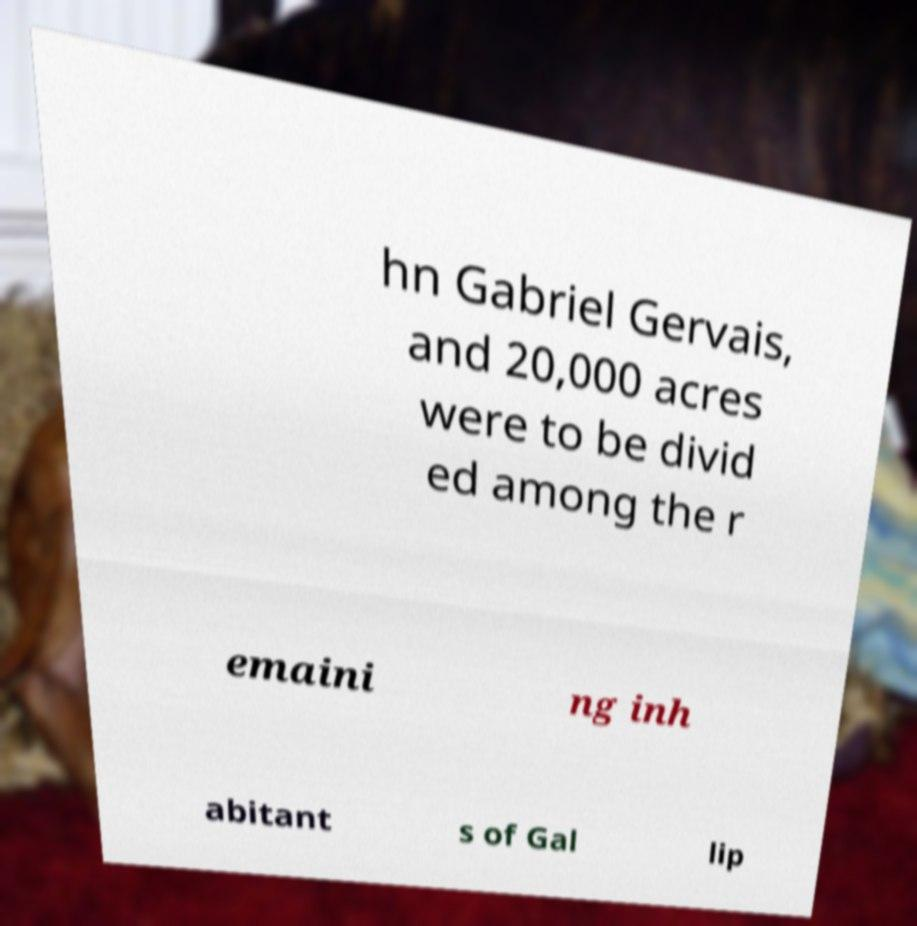Can you accurately transcribe the text from the provided image for me? hn Gabriel Gervais, and 20,000 acres were to be divid ed among the r emaini ng inh abitant s of Gal lip 